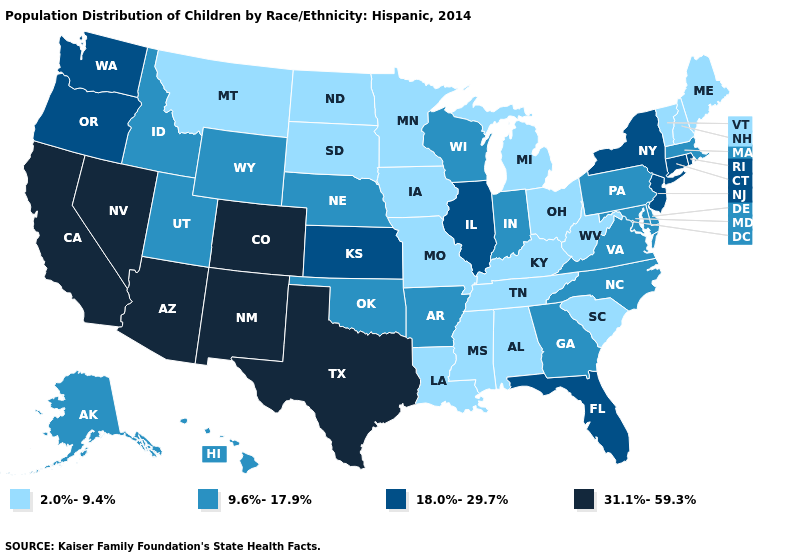Name the states that have a value in the range 2.0%-9.4%?
Answer briefly. Alabama, Iowa, Kentucky, Louisiana, Maine, Michigan, Minnesota, Mississippi, Missouri, Montana, New Hampshire, North Dakota, Ohio, South Carolina, South Dakota, Tennessee, Vermont, West Virginia. Does Mississippi have the highest value in the South?
Write a very short answer. No. Name the states that have a value in the range 31.1%-59.3%?
Answer briefly. Arizona, California, Colorado, Nevada, New Mexico, Texas. What is the lowest value in states that border New Hampshire?
Answer briefly. 2.0%-9.4%. What is the value of Florida?
Keep it brief. 18.0%-29.7%. Which states have the lowest value in the USA?
Be succinct. Alabama, Iowa, Kentucky, Louisiana, Maine, Michigan, Minnesota, Mississippi, Missouri, Montana, New Hampshire, North Dakota, Ohio, South Carolina, South Dakota, Tennessee, Vermont, West Virginia. What is the highest value in states that border Arkansas?
Give a very brief answer. 31.1%-59.3%. Does New Hampshire have the lowest value in the Northeast?
Give a very brief answer. Yes. Does the map have missing data?
Be succinct. No. Does Illinois have the highest value in the MidWest?
Short answer required. Yes. Does Nebraska have the lowest value in the MidWest?
Quick response, please. No. What is the value of Wisconsin?
Keep it brief. 9.6%-17.9%. Is the legend a continuous bar?
Keep it brief. No. What is the value of Utah?
Answer briefly. 9.6%-17.9%. Does North Dakota have the lowest value in the MidWest?
Keep it brief. Yes. 